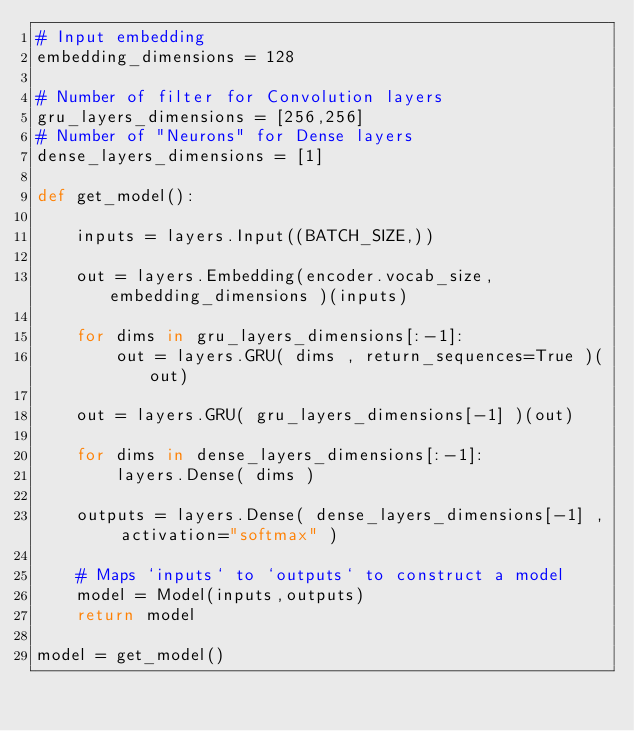<code> <loc_0><loc_0><loc_500><loc_500><_Python_># Input embedding
embedding_dimensions = 128

# Number of filter for Convolution layers
gru_layers_dimensions = [256,256]
# Number of "Neurons" for Dense layers
dense_layers_dimensions = [1]

def get_model():

	inputs = layers.Input((BATCH_SIZE,))

    out = layers.Embedding(encoder.vocab_size, embedding_dimensions )(inputs)

	for dims in gru_layers_dimensions[:-1]:
		out = layers.GRU( dims , return_sequences=True )(out)

	out = layers.GRU( gru_layers_dimensions[-1] )(out)

	for dims in dense_layers_dimensions[:-1]:
		layers.Dense( dims )

	outputs = layers.Dense( dense_layers_dimensions[-1] , activation="softmax" )

	# Maps `inputs` to `outputs` to construct a model
	model = Model(inputs,outputs)
	return model

model = get_model()	</code> 